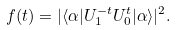<formula> <loc_0><loc_0><loc_500><loc_500>f ( t ) = | \langle \alpha | U _ { 1 } ^ { - t } U _ { 0 } ^ { t } | \alpha \rangle | ^ { 2 } .</formula> 